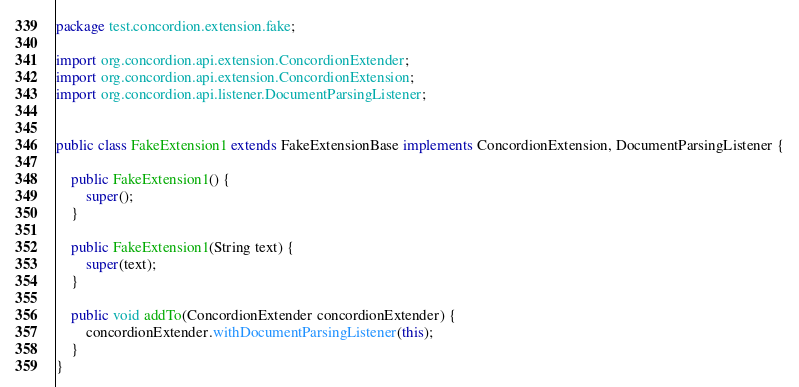<code> <loc_0><loc_0><loc_500><loc_500><_Java_>package test.concordion.extension.fake;

import org.concordion.api.extension.ConcordionExtender;
import org.concordion.api.extension.ConcordionExtension;
import org.concordion.api.listener.DocumentParsingListener;


public class FakeExtension1 extends FakeExtensionBase implements ConcordionExtension, DocumentParsingListener {

    public FakeExtension1() {
        super();
    }
    
    public FakeExtension1(String text) {
        super(text);
    }
    
    public void addTo(ConcordionExtender concordionExtender) {
        concordionExtender.withDocumentParsingListener(this);
    }
}
</code> 